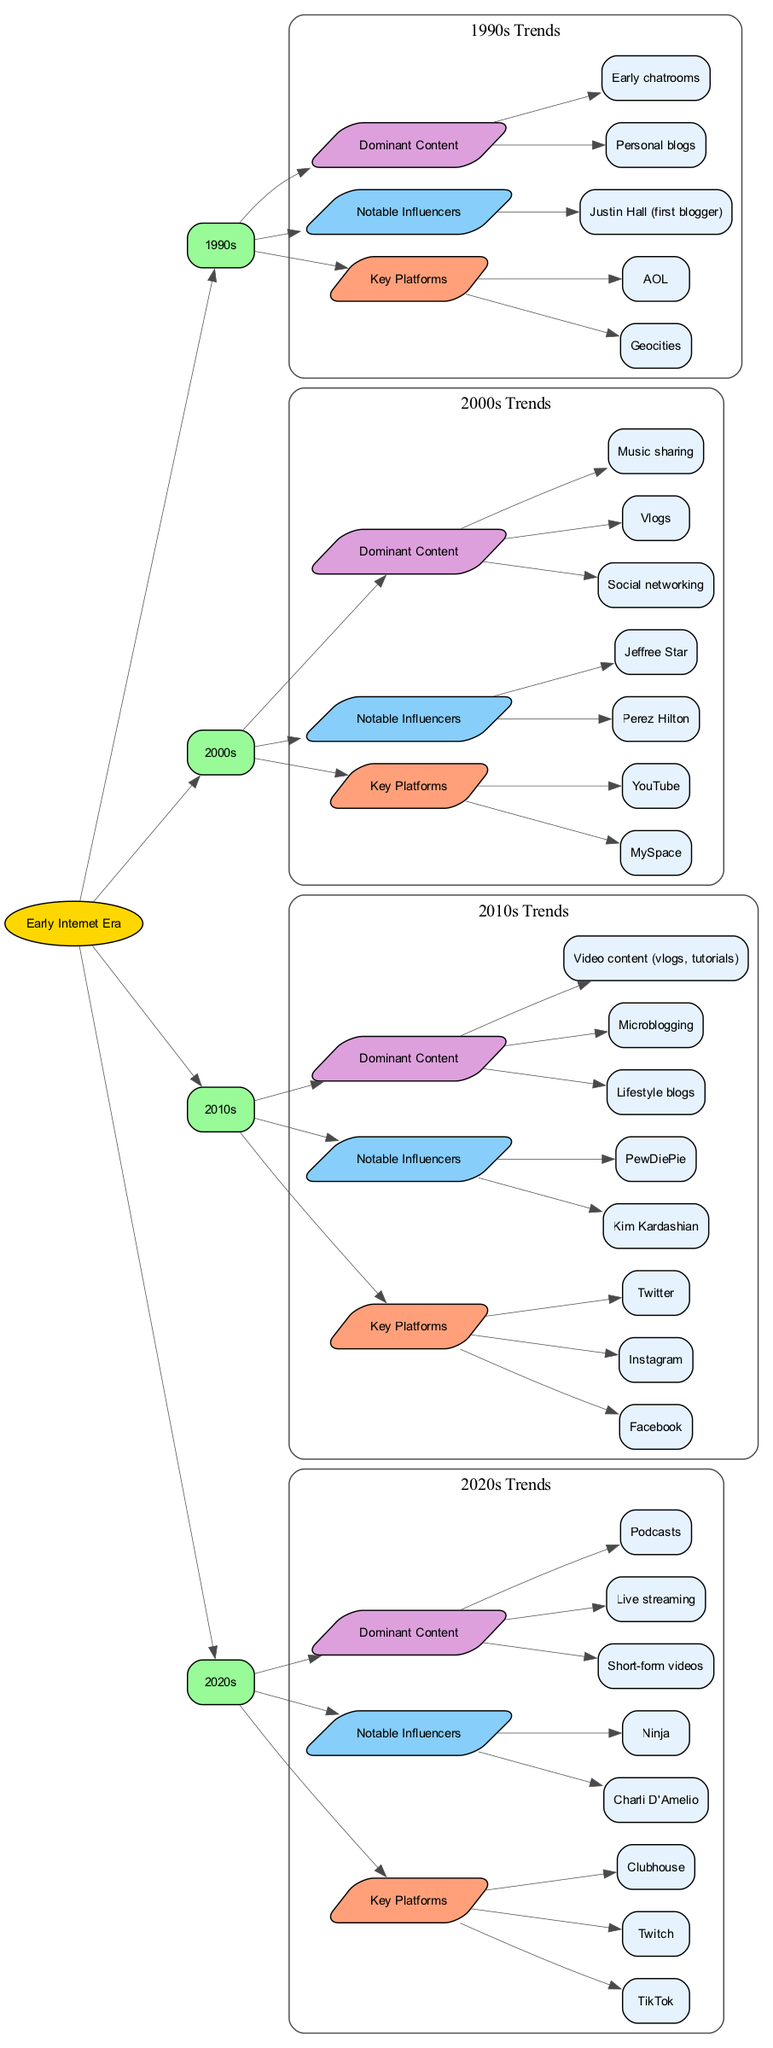What decade did Kim Kardashian become a notable influencer? By examining the diagram, we can identify that Kim Kardashian is listed as a notable influencer under the 2010s category, which indicates that her influence peaked during that decade.
Answer: 2010s How many key platforms are shown for the 2000s? In the diagram, for the 2000s decade, there are three key platforms indicated: MySpace, YouTube, and AOL. Thus, a count of those platforms gives us a total of three.
Answer: 3 What is the dominant content type in the 2020s? The diagram specifies that short-form videos are the dominant content in the 2020s. This is directly shown under the trends for that decade.
Answer: Short-form videos Which platform is associated with Justin Hall? Justin Hall is noted as the first blogger, which categorically places him in the 1990s; reflecting back to that decade's trends confirms that he is connected to Geocities and personal blogs.
Answer: Geocities What are the notable influencers listed for the 2010s? The diagram directly lists Kim Kardashian and PewDiePie as the notable influencers for the 2010s decade, thus providing a straightforward answer to this question.
Answer: Kim Kardashian, PewDiePie In which decade did live streaming become a dominant content type? The diagram illustrates that live streaming emerged as a significant content type in the 2020s, which can be discerned from the trends outlined for that decade.
Answer: 2020s What shape is used to represent each decade in the diagram? Looking at the diagram, each decade node is shaped as a box, signifying a canonical structure for representing those time periods.
Answer: Box Which committee action is taken for the 1990s trends? In the diagram, the trends for the 1990s connect back to the origin through an edge highlighting the relationship of this decade's developments, thus showing the committee action as establishing historical context.
Answer: Edge to origin 